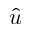Convert formula to latex. <formula><loc_0><loc_0><loc_500><loc_500>\hat { u }</formula> 